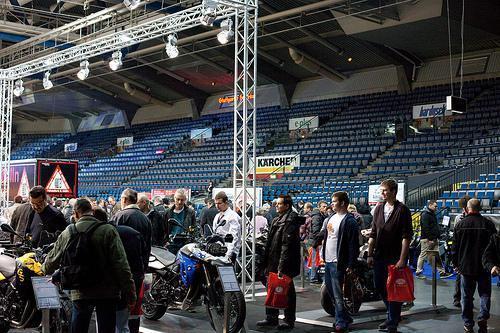How many motorcycles are in the photo?
Give a very brief answer. 2. How many wheels does the motorcycle have?
Give a very brief answer. 2. 